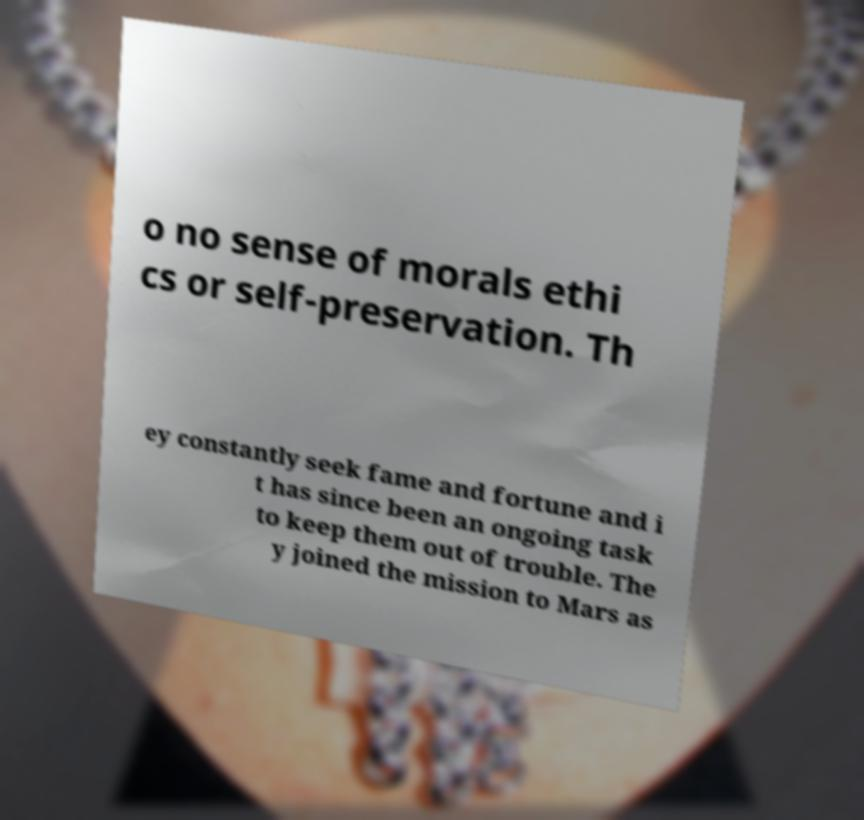There's text embedded in this image that I need extracted. Can you transcribe it verbatim? o no sense of morals ethi cs or self-preservation. Th ey constantly seek fame and fortune and i t has since been an ongoing task to keep them out of trouble. The y joined the mission to Mars as 